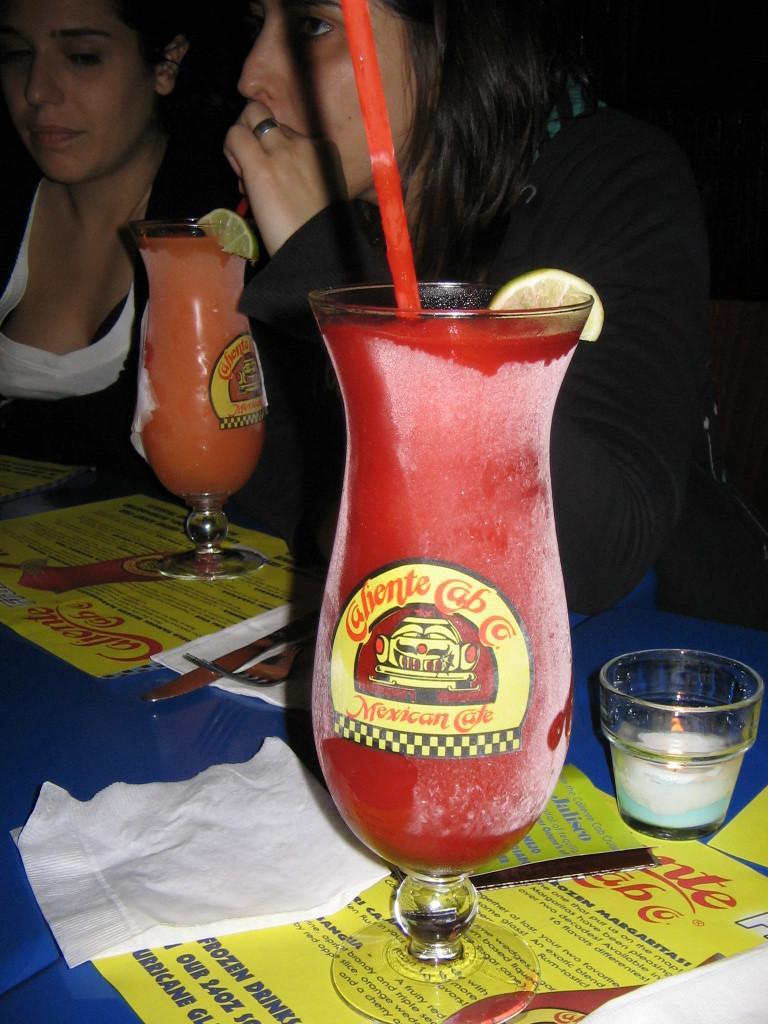Describe this image in one or two sentences. In the foreground of the picture there is a table, on the table there are pamphlets, glasses, juice, lemon, straws, tissues and other objects. At the top we can see two women. 